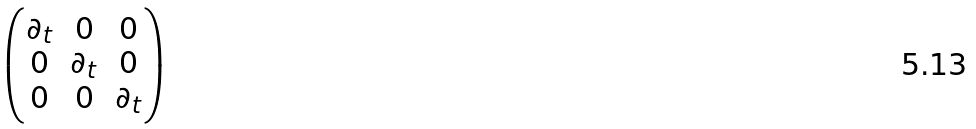<formula> <loc_0><loc_0><loc_500><loc_500>\begin{pmatrix} { \partial _ { t } } & 0 & 0 \\ { 0 } & \partial _ { t } & 0 \\ { 0 } & 0 & \partial _ { t } \end{pmatrix}</formula> 